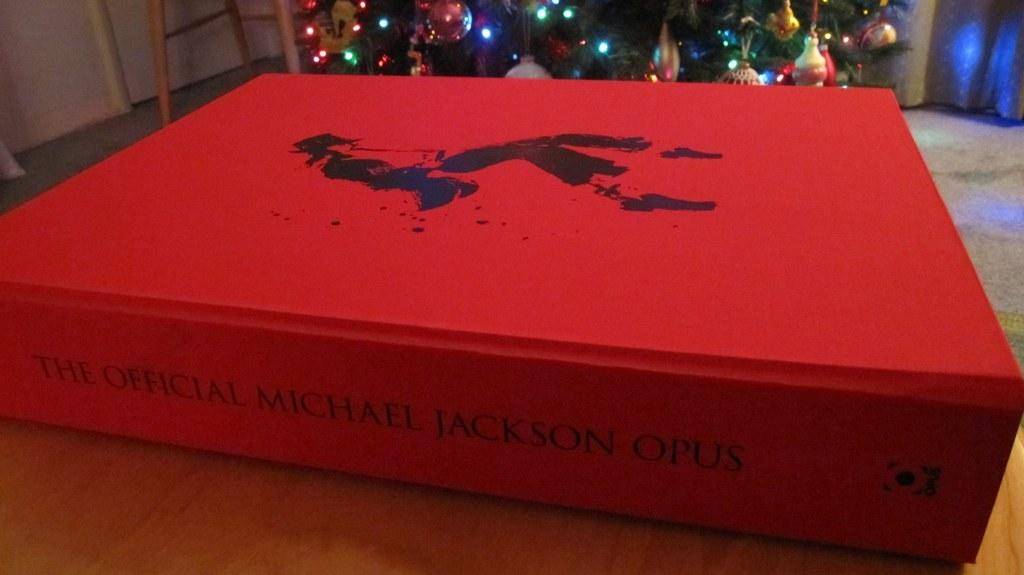<image>
Offer a succinct explanation of the picture presented. A red cover with The Official Michael Jackson Opus written on the side 